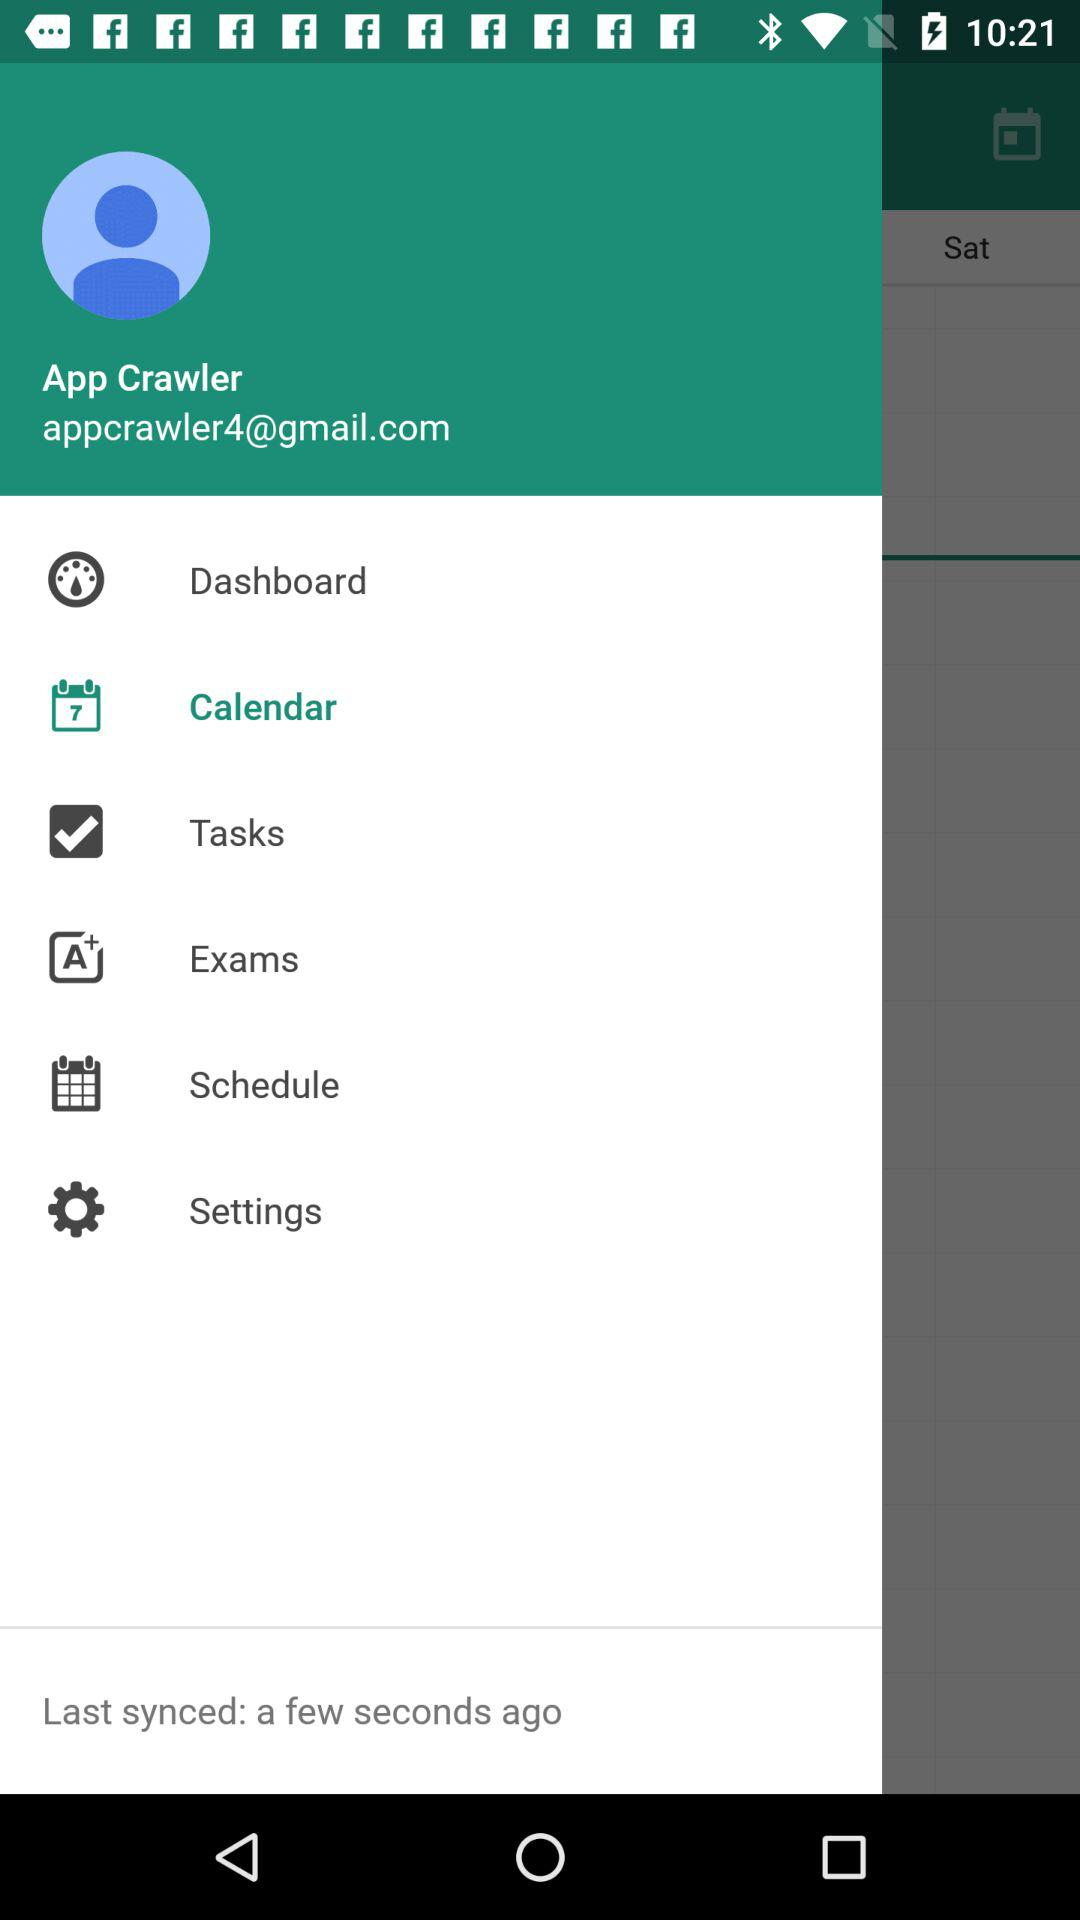What is the mentioned date on the calendar?
When the provided information is insufficient, respond with <no answer>. <no answer> 